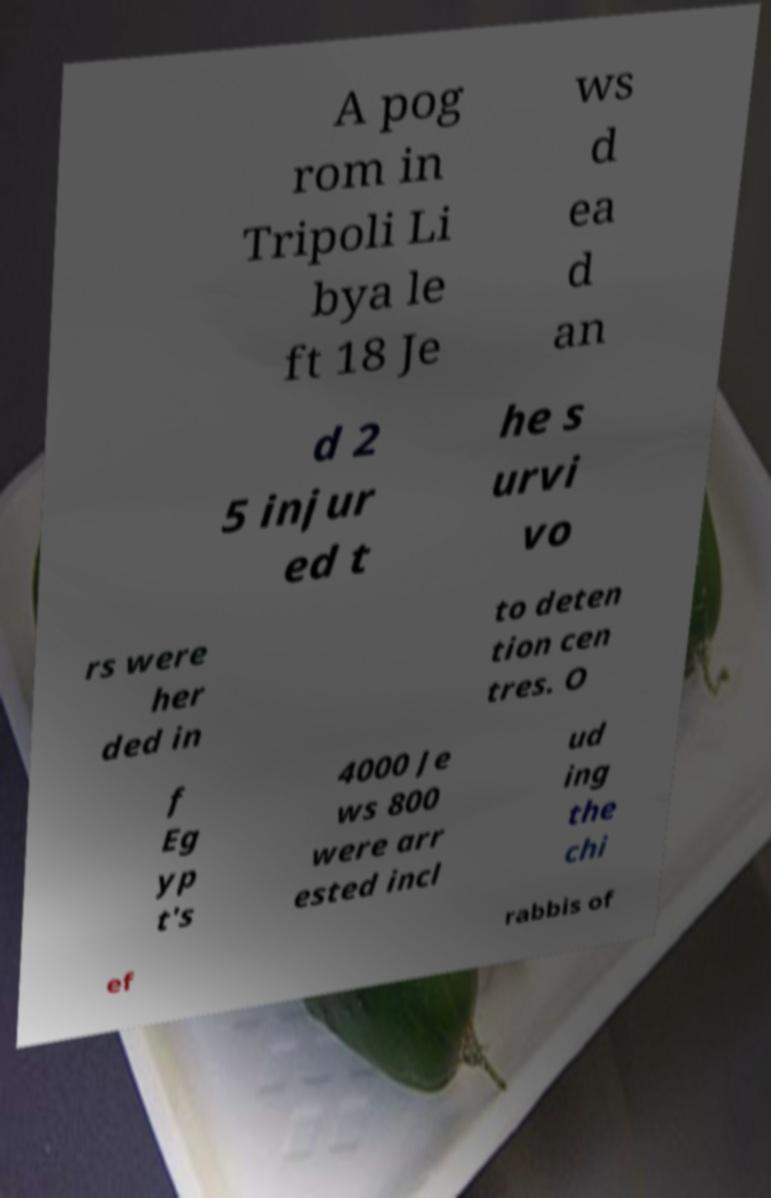Could you extract and type out the text from this image? A pog rom in Tripoli Li bya le ft 18 Je ws d ea d an d 2 5 injur ed t he s urvi vo rs were her ded in to deten tion cen tres. O f Eg yp t's 4000 Je ws 800 were arr ested incl ud ing the chi ef rabbis of 